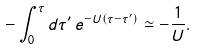Convert formula to latex. <formula><loc_0><loc_0><loc_500><loc_500>- \int _ { 0 } ^ { \tau } d \tau ^ { \prime } \, e ^ { - U ( \tau - \tau ^ { \prime } ) } \simeq - \frac { 1 } { U } .</formula> 